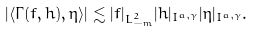<formula> <loc_0><loc_0><loc_500><loc_500>| \langle \Gamma ( f , h ) , \eta \rangle | \lesssim | f | _ { L ^ { 2 } _ { - m } } | h | _ { I ^ { a , \gamma } } | \eta | _ { I ^ { a , \gamma } } .</formula> 